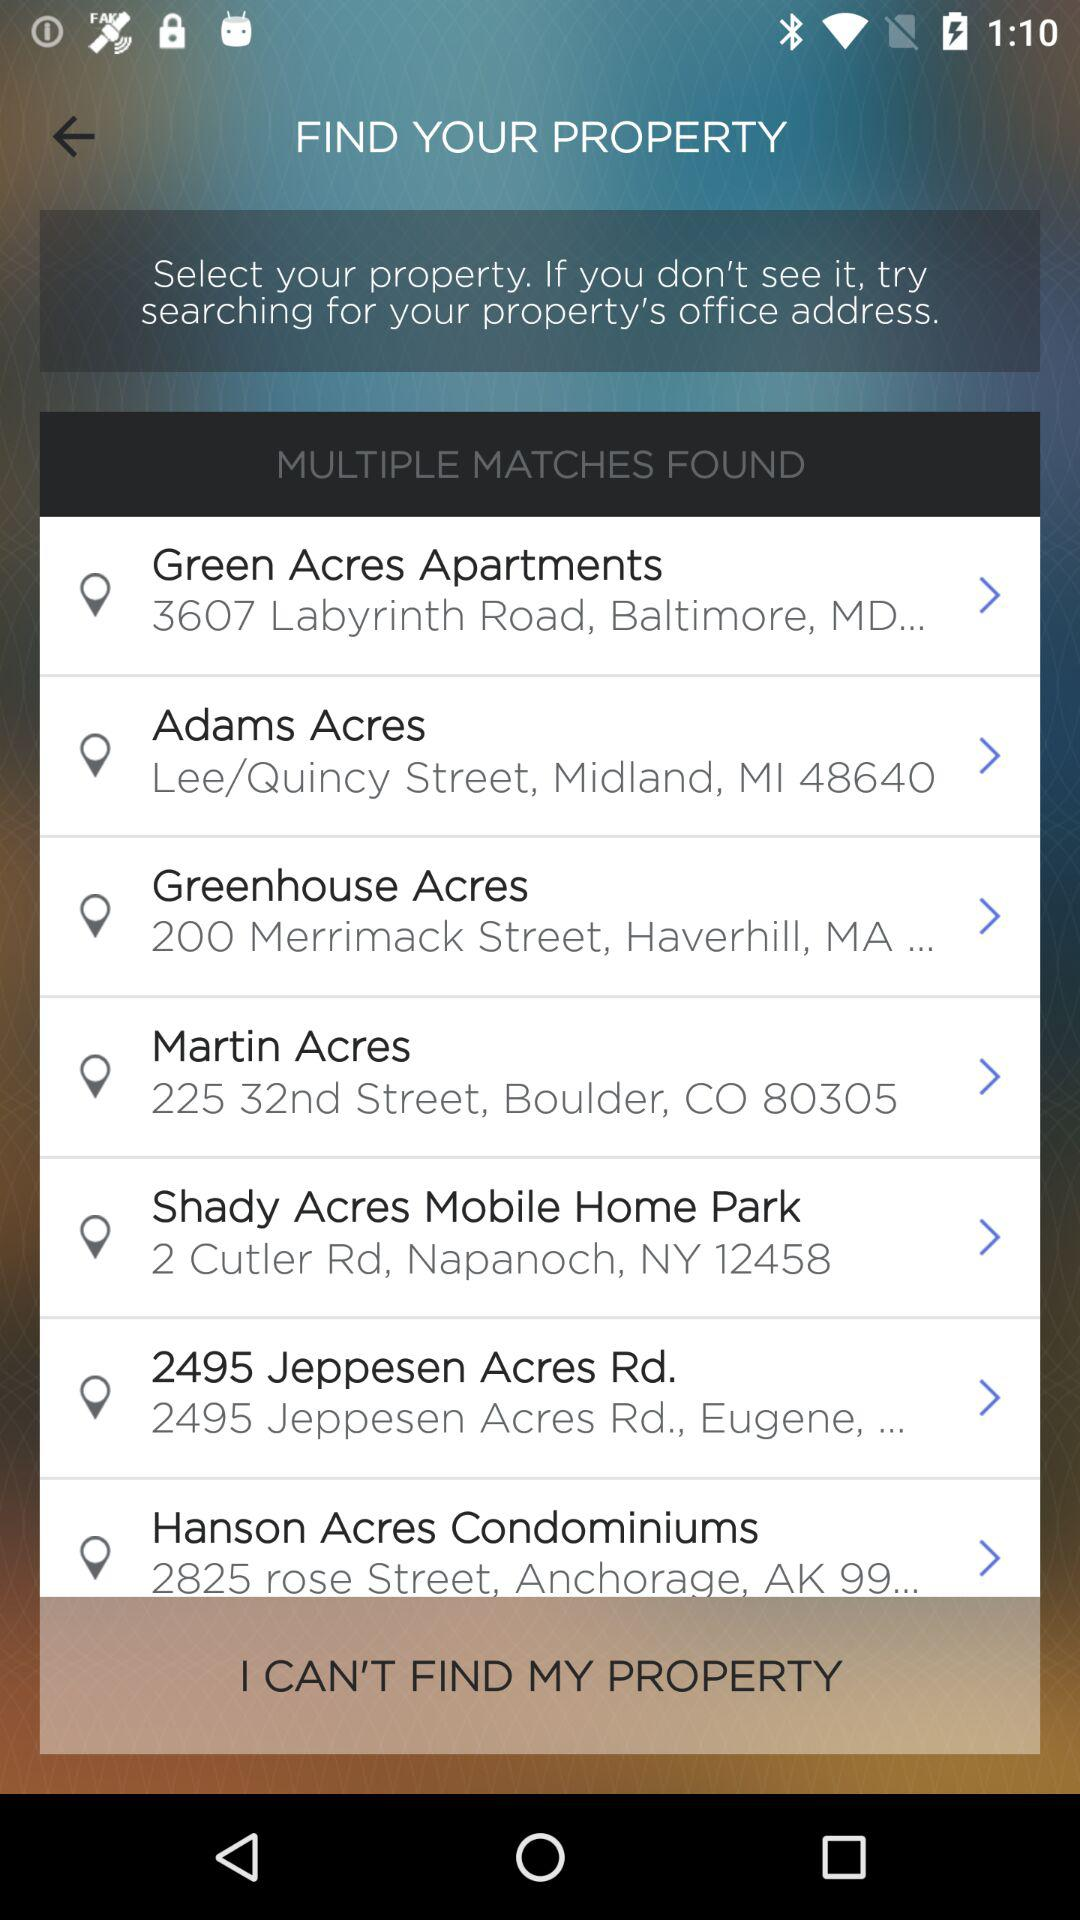What is the location of "Martin Acres"? The location is 225 32nd Street, Boulder, CO 80305. 